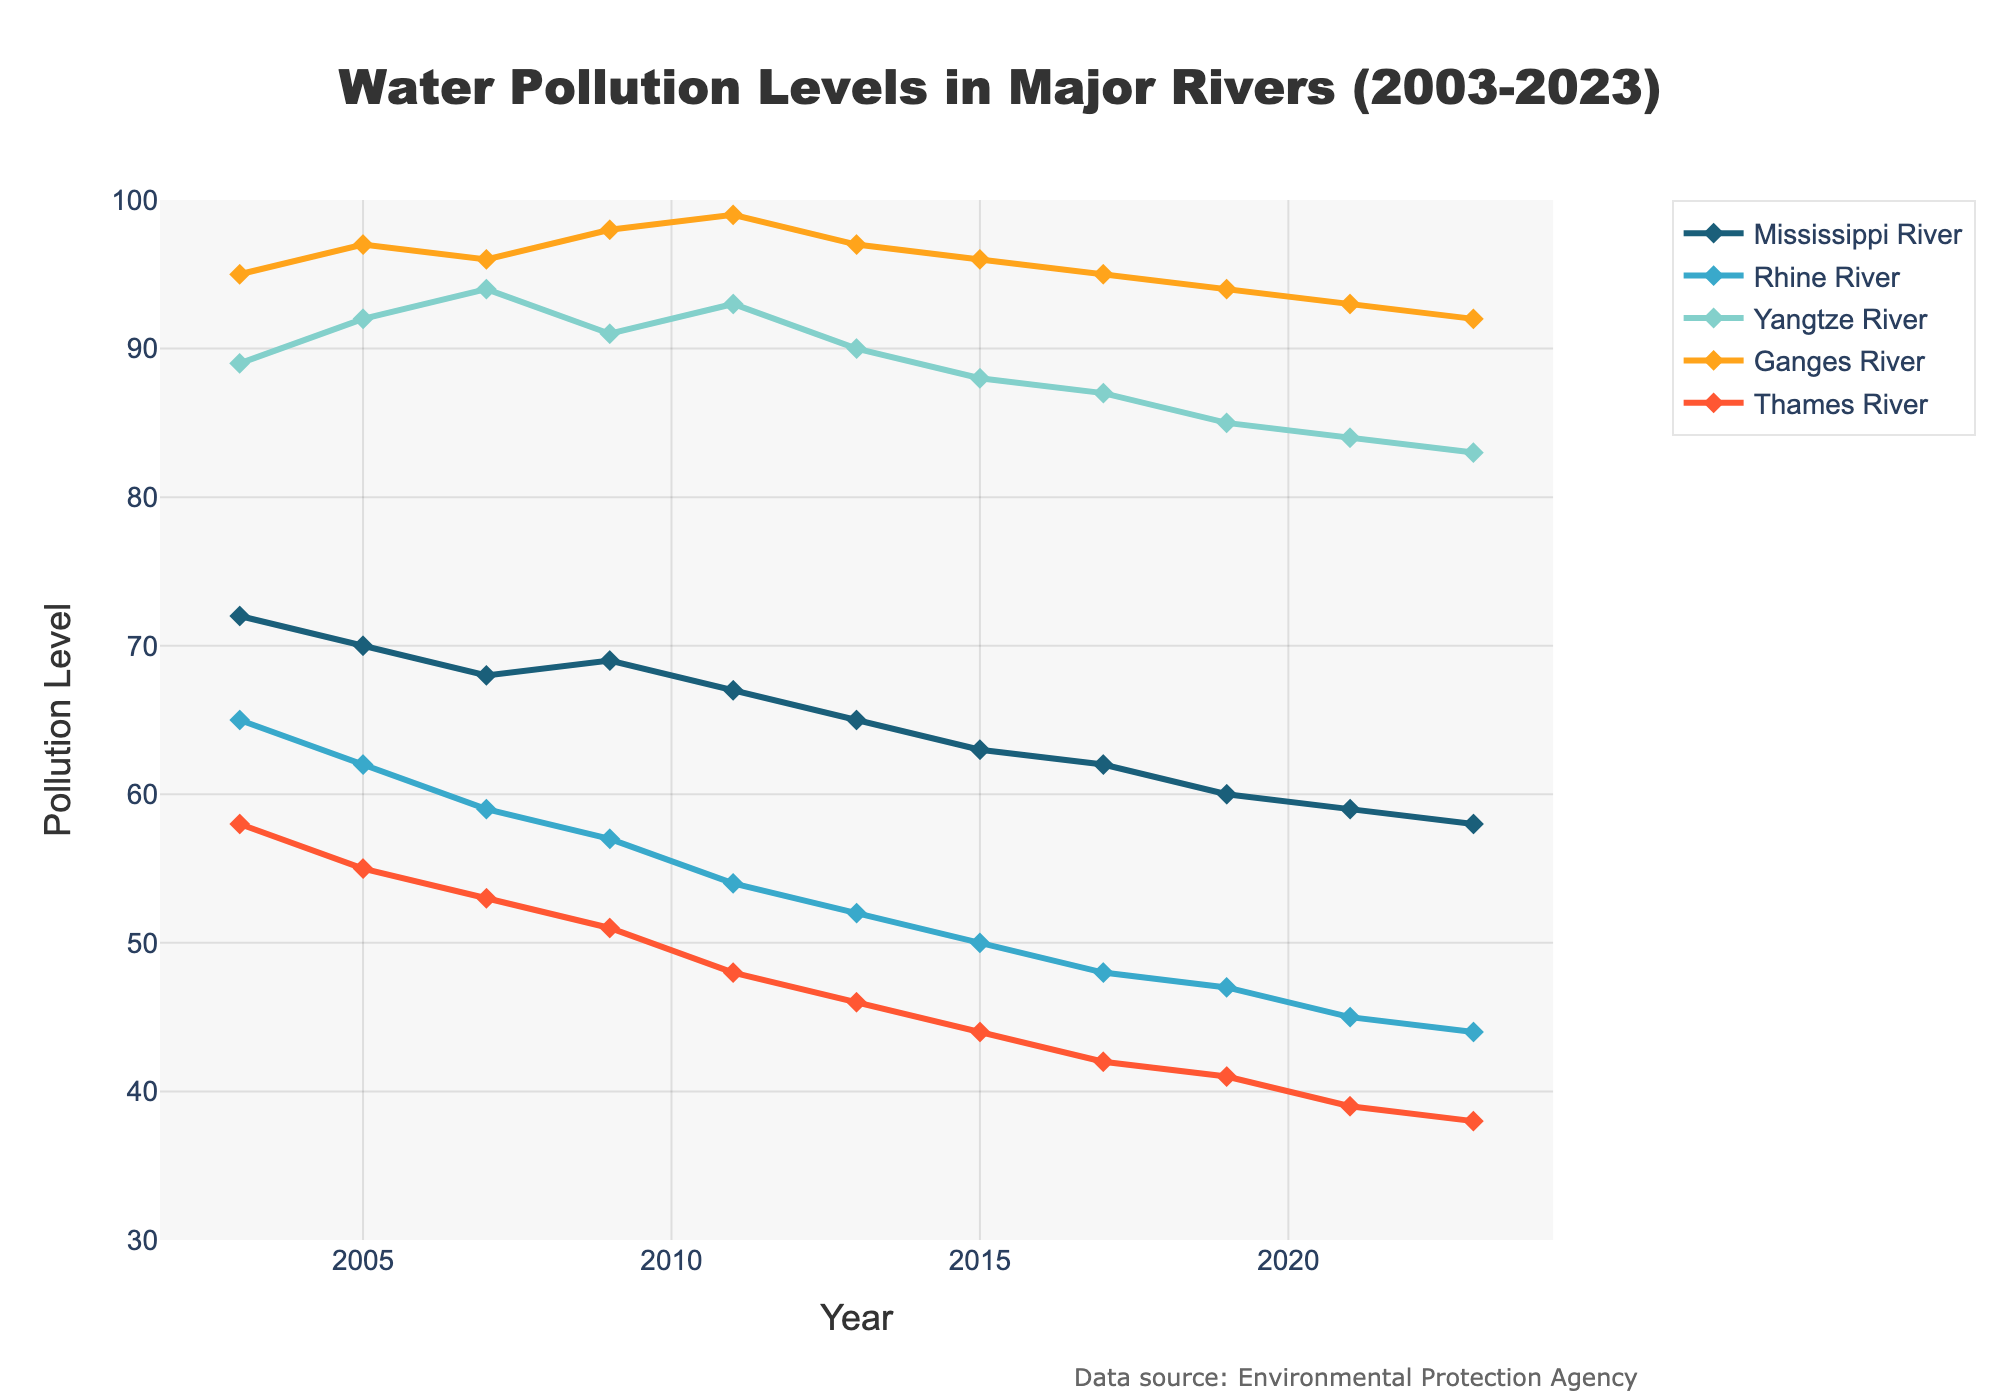What is the average pollution level in 2023 across all rivers? Sum the pollution levels for all rivers in 2023 (58, 44, 83, 92, 38) to get 315. The number of rivers is 5. Divide the sum by the number of rivers, 315/5 = 63.
Answer: 63 Which river experienced the highest decrease in pollution levels over the two decades? Calculate the difference in pollution levels from 2003 to 2023 for each river. The Ganges River has the largest decrease from 95 to 92, which is a decrease of 3. The other rivers have smaller decreases.
Answer: Ganges River Between 2003 and 2023, which river showed the smallest fluctuation in pollution levels? Compare the range (maximum value - minimum value) of pollution levels for each river. The Rhine River fluctuated between 65 and 44 (a difference of 21), which is smaller than the fluctuations for other rivers.
Answer: Rhine River In which year did the Thames River show the lowest pollution level, and what was that level? Look at the data points for the Thames River. The lowest pollution level is in 2023, with a level of 38.
Answer: 2023, 38 Compare the pollution levels of the Mississippi River and Yangtze River in 2021. Which river was more polluted? Look at the data points for both rivers in 2021. The Mississippi River has a pollution level of 59 and the Yangtze River has a level of 84. The Yangtze River is more polluted.
Answer: Yangtze River Did the pollution level in the Rhine River ever increase between 2003 and 2023? Analyze the trend for the Rhine River from 2003 to 2023. The trend is always decreasing without any increases.
Answer: No Considering the total pollution levels in 2003 and 2023 across all rivers, has there been an overall increase or decrease? Sum the pollution levels for all rivers in both years. In 2003, the total is 72+65+89+95+58 = 379. In 2023, the total is 58+44+83+92+38 = 315. Since 315 < 379, there has been a decrease.
Answer: Decrease What is the difference in pollution levels between the Mississippi River and the Thames River in 2015? Look at the pollution levels for both rivers in 2015. The difference is 63 - 44 = 19.
Answer: 19 How many years did it take for the pollution level in the Ganges River to drop from 95 to 92? Look at the years when the Ganges River pollution level is 95 (2003) and 92 (2023). It took 2023 - 2003 = 20 years.
Answer: 20 Which river maintained the highest pollution level consistently throughout the given timeframe? Compare the data points for each year and note the highest recurring level. The Ganges River consistently shows the highest pollution levels compared to other rivers.
Answer: Ganges River 